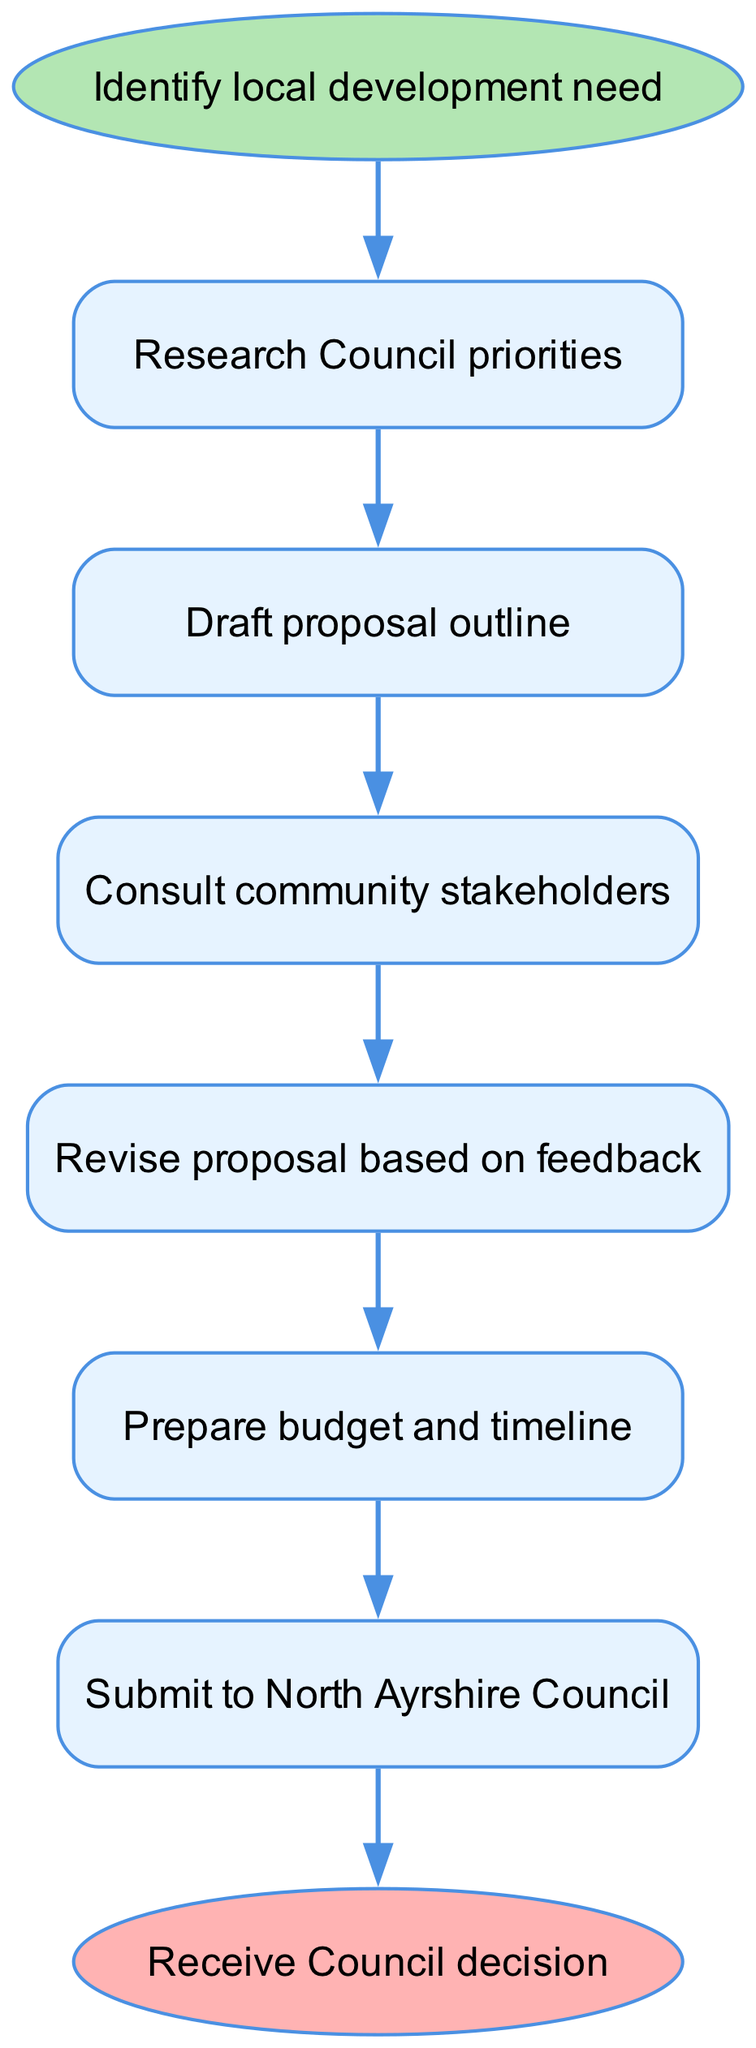What is the starting point of the proposal process? The diagram indicates that the process starts with "Identify local development need." This is shown as the first node before progressing to other steps.
Answer: Identify local development need How many steps are there in the proposal process? By counting the nodes after the start node and before the end node, there are six distinct steps in the process. This includes "Research Council priorities," "Draft proposal outline," "Consult community stakeholders," "Revise proposal based on feedback," and "Prepare budget and timeline."
Answer: 6 What is the final step before receiving the Council decision? The last step before the end node labeled "Receive Council decision" is "Submit to North Ayrshire Council." This is directly linked to the end of the process.
Answer: Submit to North Ayrshire Council What follows after consulting community stakeholders? The diagram shows that after "Consult community stakeholders," the next step is "Revise proposal based on feedback," indicating a logical progression in the proposal process that incorporates stakeholder input.
Answer: Revise proposal based on feedback What is the purpose of the 'Research Council priorities' step? It serves as the initial research phase for proposal development, ensuring that the proposal aligns with the established priorities of the Council, thus helping to ensure its relevance and potential support.
Answer: Align proposal with Council priorities Is there a step that leads to "Await Council decision"? Yes, the step "Submit to North Ayrshire Council" directly leads to the "Await Council decision" process, showing that submitting the proposal is essential for the next stage in the process.
Answer: Submit to North Ayrshire Council What role do community stakeholders play in the proposal process? The step "Consult community stakeholders" indicates that gathering feedback from these stakeholders is essential for revising the proposal. This ensures that the proposal addresses the concerns and suggestions from the community, making it more robust and applicable.
Answer: Provide feedback for revision What happens after the budget and timeline are prepared? According to the flowchart, the next action after preparing the budget and timeline is to "Submit to North Ayrshire Council," which is crucial for moving forward in the process of getting the proposal approved.
Answer: Submit to North Ayrshire Council How does feedback influence the proposal process? The diagram describes a step where the proposal is revised based on feedback collected from community stakeholders. This step shows that feedback is not just collected but actively incorporated into the proposal to improve its quality and acceptance.
Answer: Revise proposal based on feedback 